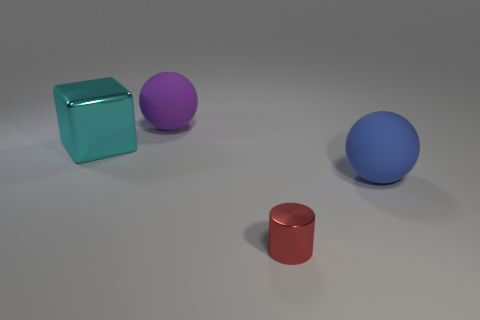Add 1 large brown metal cylinders. How many objects exist? 5 Subtract all cubes. How many objects are left? 3 Subtract 0 cyan cylinders. How many objects are left? 4 Subtract all large purple matte cubes. Subtract all spheres. How many objects are left? 2 Add 4 big spheres. How many big spheres are left? 6 Add 3 small blue blocks. How many small blue blocks exist? 3 